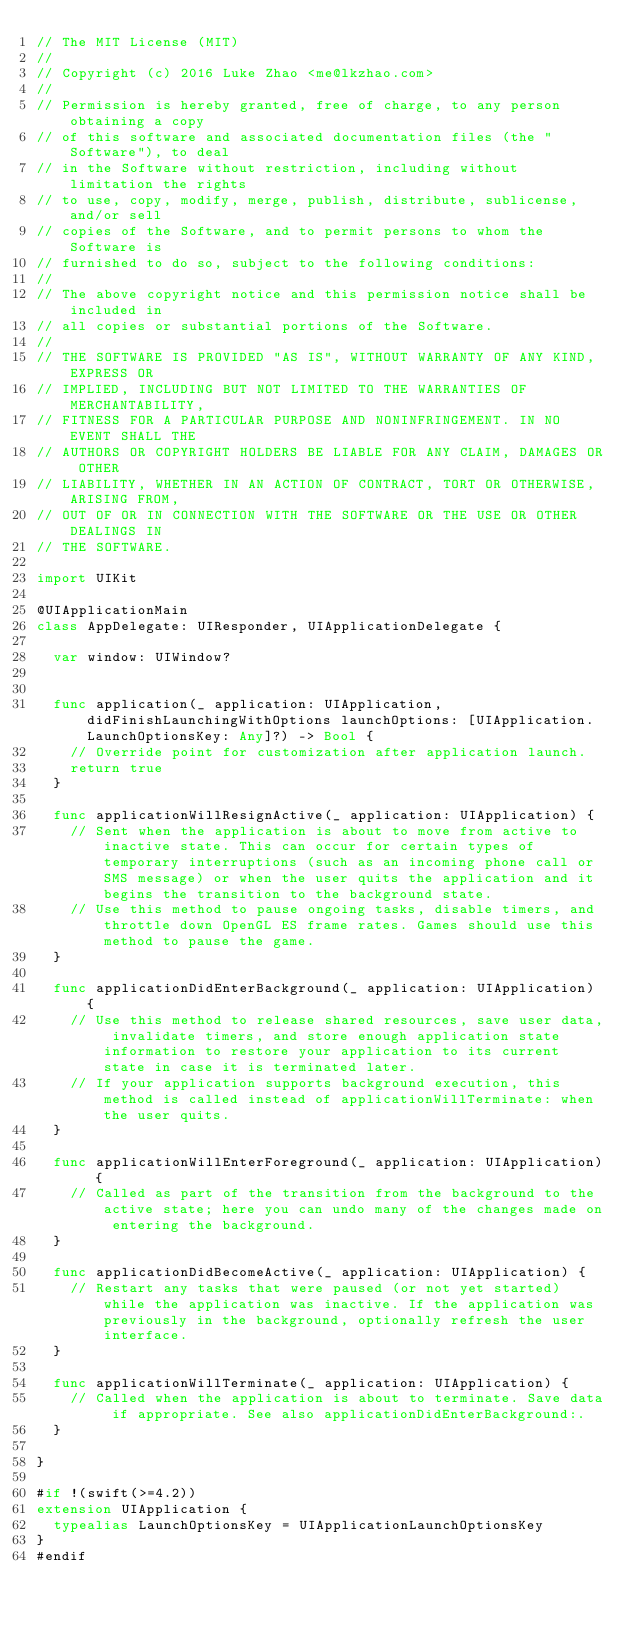<code> <loc_0><loc_0><loc_500><loc_500><_Swift_>// The MIT License (MIT)
//
// Copyright (c) 2016 Luke Zhao <me@lkzhao.com>
//
// Permission is hereby granted, free of charge, to any person obtaining a copy
// of this software and associated documentation files (the "Software"), to deal
// in the Software without restriction, including without limitation the rights
// to use, copy, modify, merge, publish, distribute, sublicense, and/or sell
// copies of the Software, and to permit persons to whom the Software is
// furnished to do so, subject to the following conditions:
//
// The above copyright notice and this permission notice shall be included in
// all copies or substantial portions of the Software.
//
// THE SOFTWARE IS PROVIDED "AS IS", WITHOUT WARRANTY OF ANY KIND, EXPRESS OR
// IMPLIED, INCLUDING BUT NOT LIMITED TO THE WARRANTIES OF MERCHANTABILITY,
// FITNESS FOR A PARTICULAR PURPOSE AND NONINFRINGEMENT. IN NO EVENT SHALL THE
// AUTHORS OR COPYRIGHT HOLDERS BE LIABLE FOR ANY CLAIM, DAMAGES OR OTHER
// LIABILITY, WHETHER IN AN ACTION OF CONTRACT, TORT OR OTHERWISE, ARISING FROM,
// OUT OF OR IN CONNECTION WITH THE SOFTWARE OR THE USE OR OTHER DEALINGS IN
// THE SOFTWARE.

import UIKit

@UIApplicationMain
class AppDelegate: UIResponder, UIApplicationDelegate {

  var window: UIWindow?


  func application(_ application: UIApplication, didFinishLaunchingWithOptions launchOptions: [UIApplication.LaunchOptionsKey: Any]?) -> Bool {
    // Override point for customization after application launch.
    return true
  }

  func applicationWillResignActive(_ application: UIApplication) {
    // Sent when the application is about to move from active to inactive state. This can occur for certain types of temporary interruptions (such as an incoming phone call or SMS message) or when the user quits the application and it begins the transition to the background state.
    // Use this method to pause ongoing tasks, disable timers, and throttle down OpenGL ES frame rates. Games should use this method to pause the game.
  }

  func applicationDidEnterBackground(_ application: UIApplication) {
    // Use this method to release shared resources, save user data, invalidate timers, and store enough application state information to restore your application to its current state in case it is terminated later.
    // If your application supports background execution, this method is called instead of applicationWillTerminate: when the user quits.
  }

  func applicationWillEnterForeground(_ application: UIApplication) {
    // Called as part of the transition from the background to the active state; here you can undo many of the changes made on entering the background.
  }

  func applicationDidBecomeActive(_ application: UIApplication) {
    // Restart any tasks that were paused (or not yet started) while the application was inactive. If the application was previously in the background, optionally refresh the user interface.
  }

  func applicationWillTerminate(_ application: UIApplication) {
    // Called when the application is about to terminate. Save data if appropriate. See also applicationDidEnterBackground:.
  }

}

#if !(swift(>=4.2))
extension UIApplication {
  typealias LaunchOptionsKey = UIApplicationLaunchOptionsKey
}
#endif

</code> 